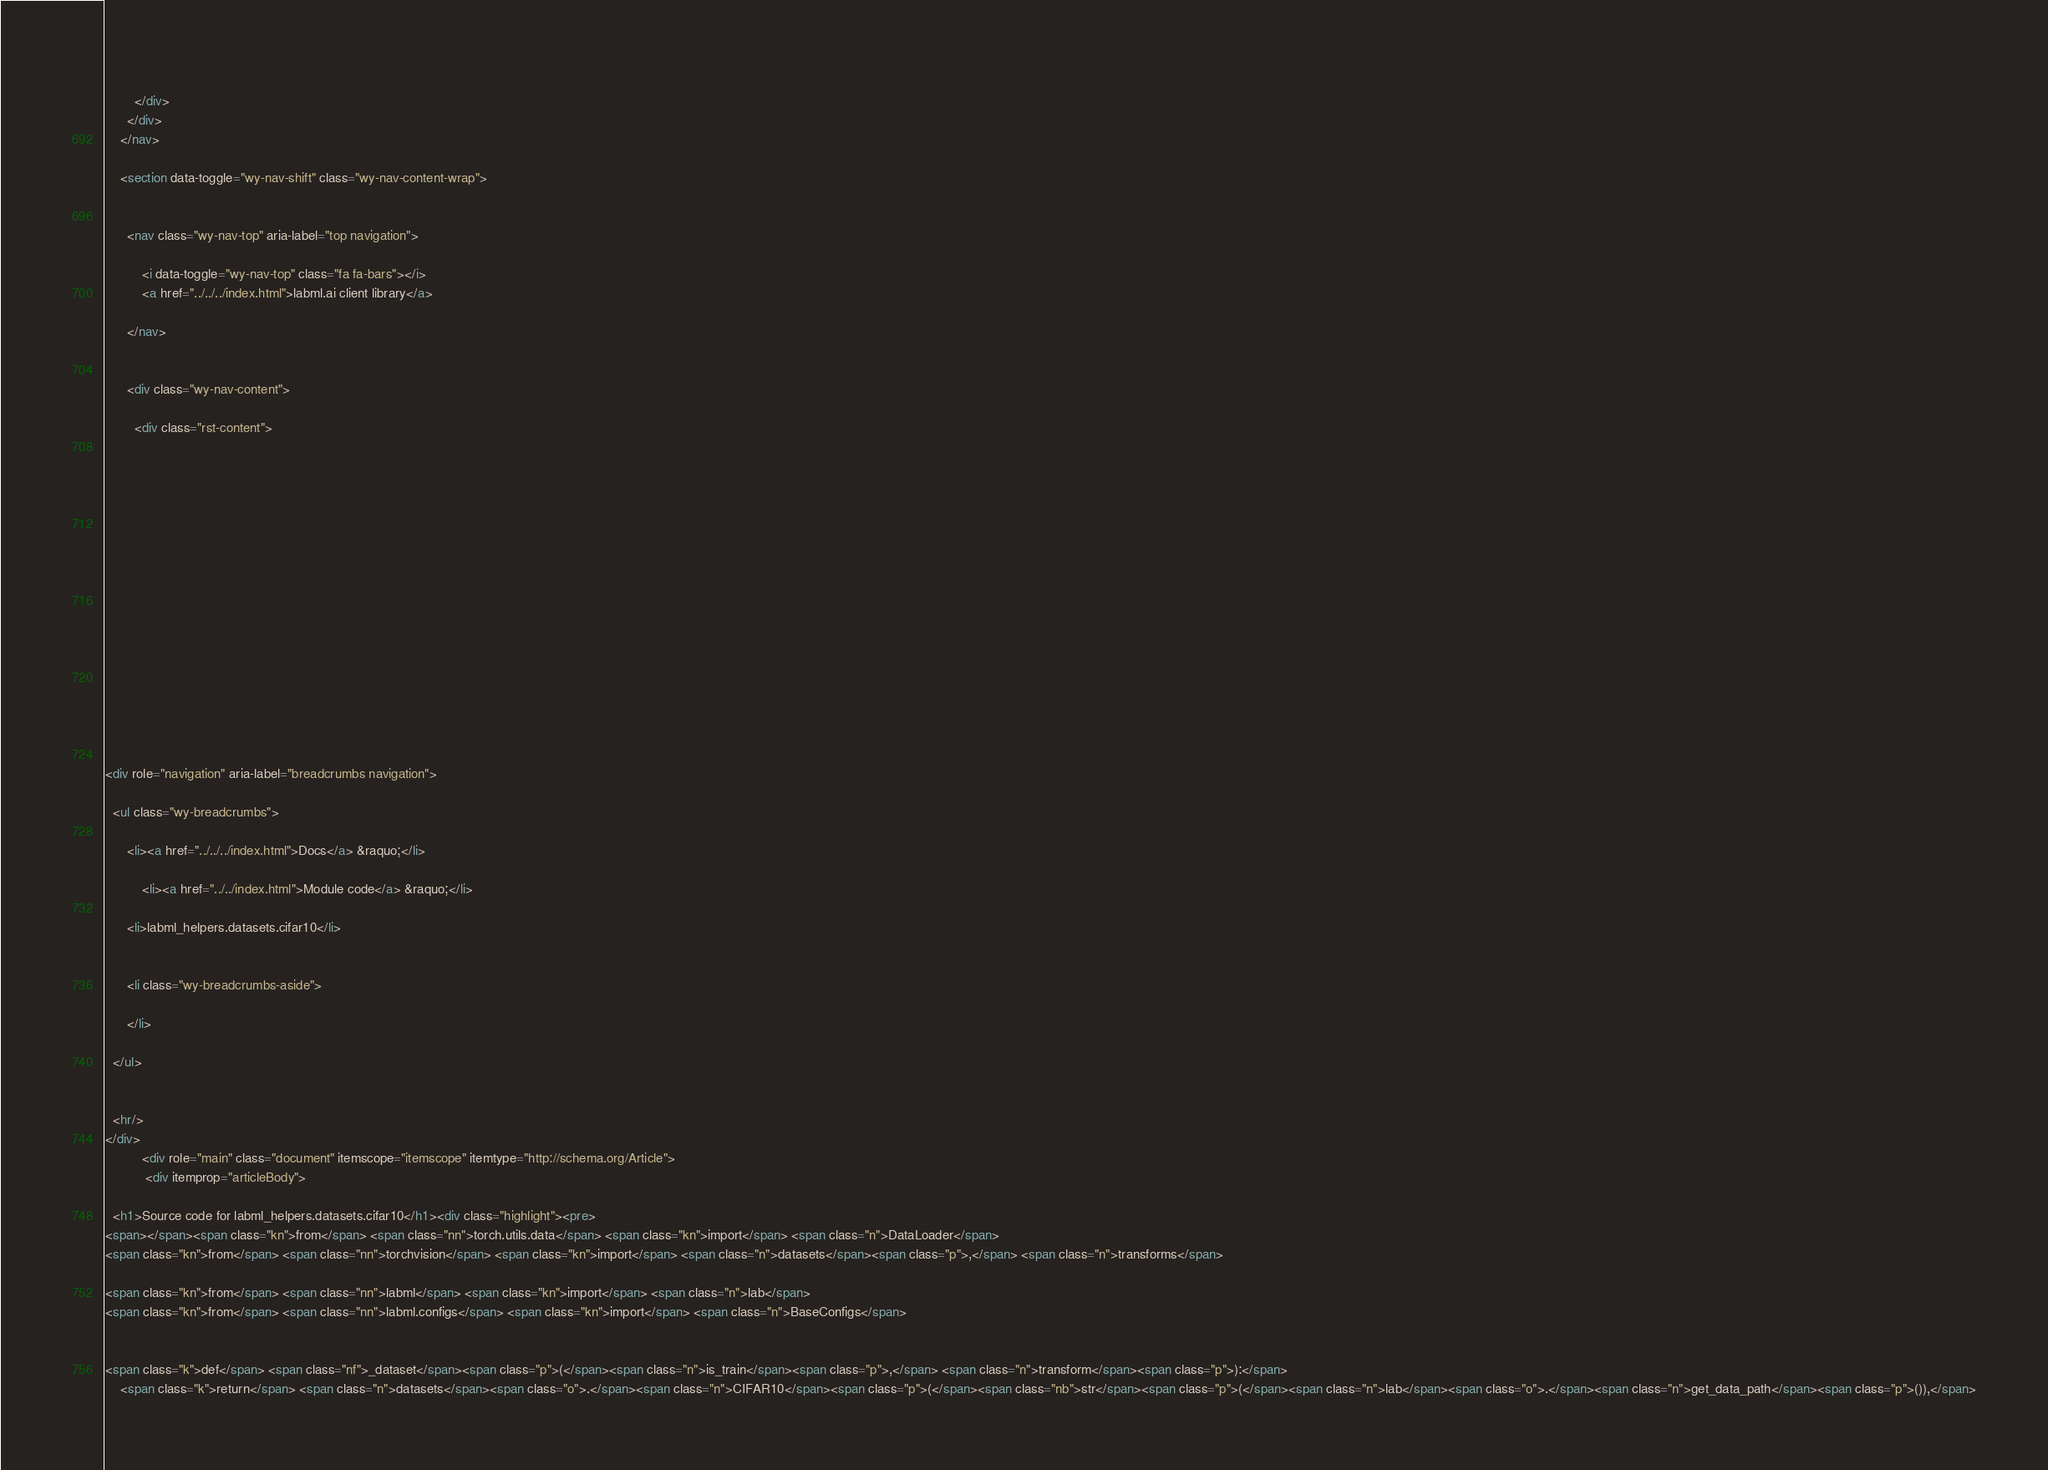<code> <loc_0><loc_0><loc_500><loc_500><_HTML_>          
        </div>
      </div>
    </nav>

    <section data-toggle="wy-nav-shift" class="wy-nav-content-wrap">

      
      <nav class="wy-nav-top" aria-label="top navigation">
        
          <i data-toggle="wy-nav-top" class="fa fa-bars"></i>
          <a href="../../../index.html">labml.ai client library</a>
        
      </nav>


      <div class="wy-nav-content">
        
        <div class="rst-content">
        
          















<div role="navigation" aria-label="breadcrumbs navigation">

  <ul class="wy-breadcrumbs">
    
      <li><a href="../../../index.html">Docs</a> &raquo;</li>
        
          <li><a href="../../index.html">Module code</a> &raquo;</li>
        
      <li>labml_helpers.datasets.cifar10</li>
    
    
      <li class="wy-breadcrumbs-aside">
        
      </li>
    
  </ul>

  
  <hr/>
</div>
          <div role="main" class="document" itemscope="itemscope" itemtype="http://schema.org/Article">
           <div itemprop="articleBody">
            
  <h1>Source code for labml_helpers.datasets.cifar10</h1><div class="highlight"><pre>
<span></span><span class="kn">from</span> <span class="nn">torch.utils.data</span> <span class="kn">import</span> <span class="n">DataLoader</span>
<span class="kn">from</span> <span class="nn">torchvision</span> <span class="kn">import</span> <span class="n">datasets</span><span class="p">,</span> <span class="n">transforms</span>

<span class="kn">from</span> <span class="nn">labml</span> <span class="kn">import</span> <span class="n">lab</span>
<span class="kn">from</span> <span class="nn">labml.configs</span> <span class="kn">import</span> <span class="n">BaseConfigs</span>


<span class="k">def</span> <span class="nf">_dataset</span><span class="p">(</span><span class="n">is_train</span><span class="p">,</span> <span class="n">transform</span><span class="p">):</span>
    <span class="k">return</span> <span class="n">datasets</span><span class="o">.</span><span class="n">CIFAR10</span><span class="p">(</span><span class="nb">str</span><span class="p">(</span><span class="n">lab</span><span class="o">.</span><span class="n">get_data_path</span><span class="p">()),</span></code> 